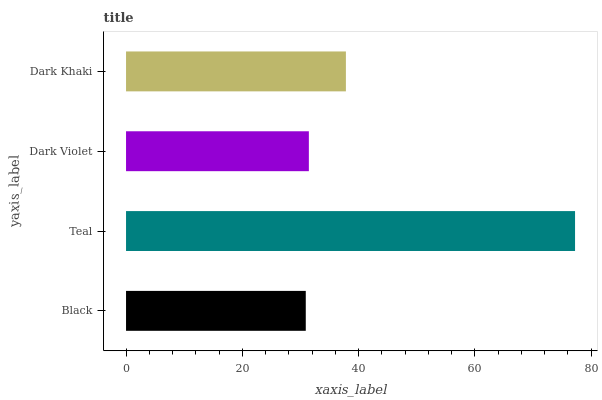Is Black the minimum?
Answer yes or no. Yes. Is Teal the maximum?
Answer yes or no. Yes. Is Dark Violet the minimum?
Answer yes or no. No. Is Dark Violet the maximum?
Answer yes or no. No. Is Teal greater than Dark Violet?
Answer yes or no. Yes. Is Dark Violet less than Teal?
Answer yes or no. Yes. Is Dark Violet greater than Teal?
Answer yes or no. No. Is Teal less than Dark Violet?
Answer yes or no. No. Is Dark Khaki the high median?
Answer yes or no. Yes. Is Dark Violet the low median?
Answer yes or no. Yes. Is Teal the high median?
Answer yes or no. No. Is Black the low median?
Answer yes or no. No. 